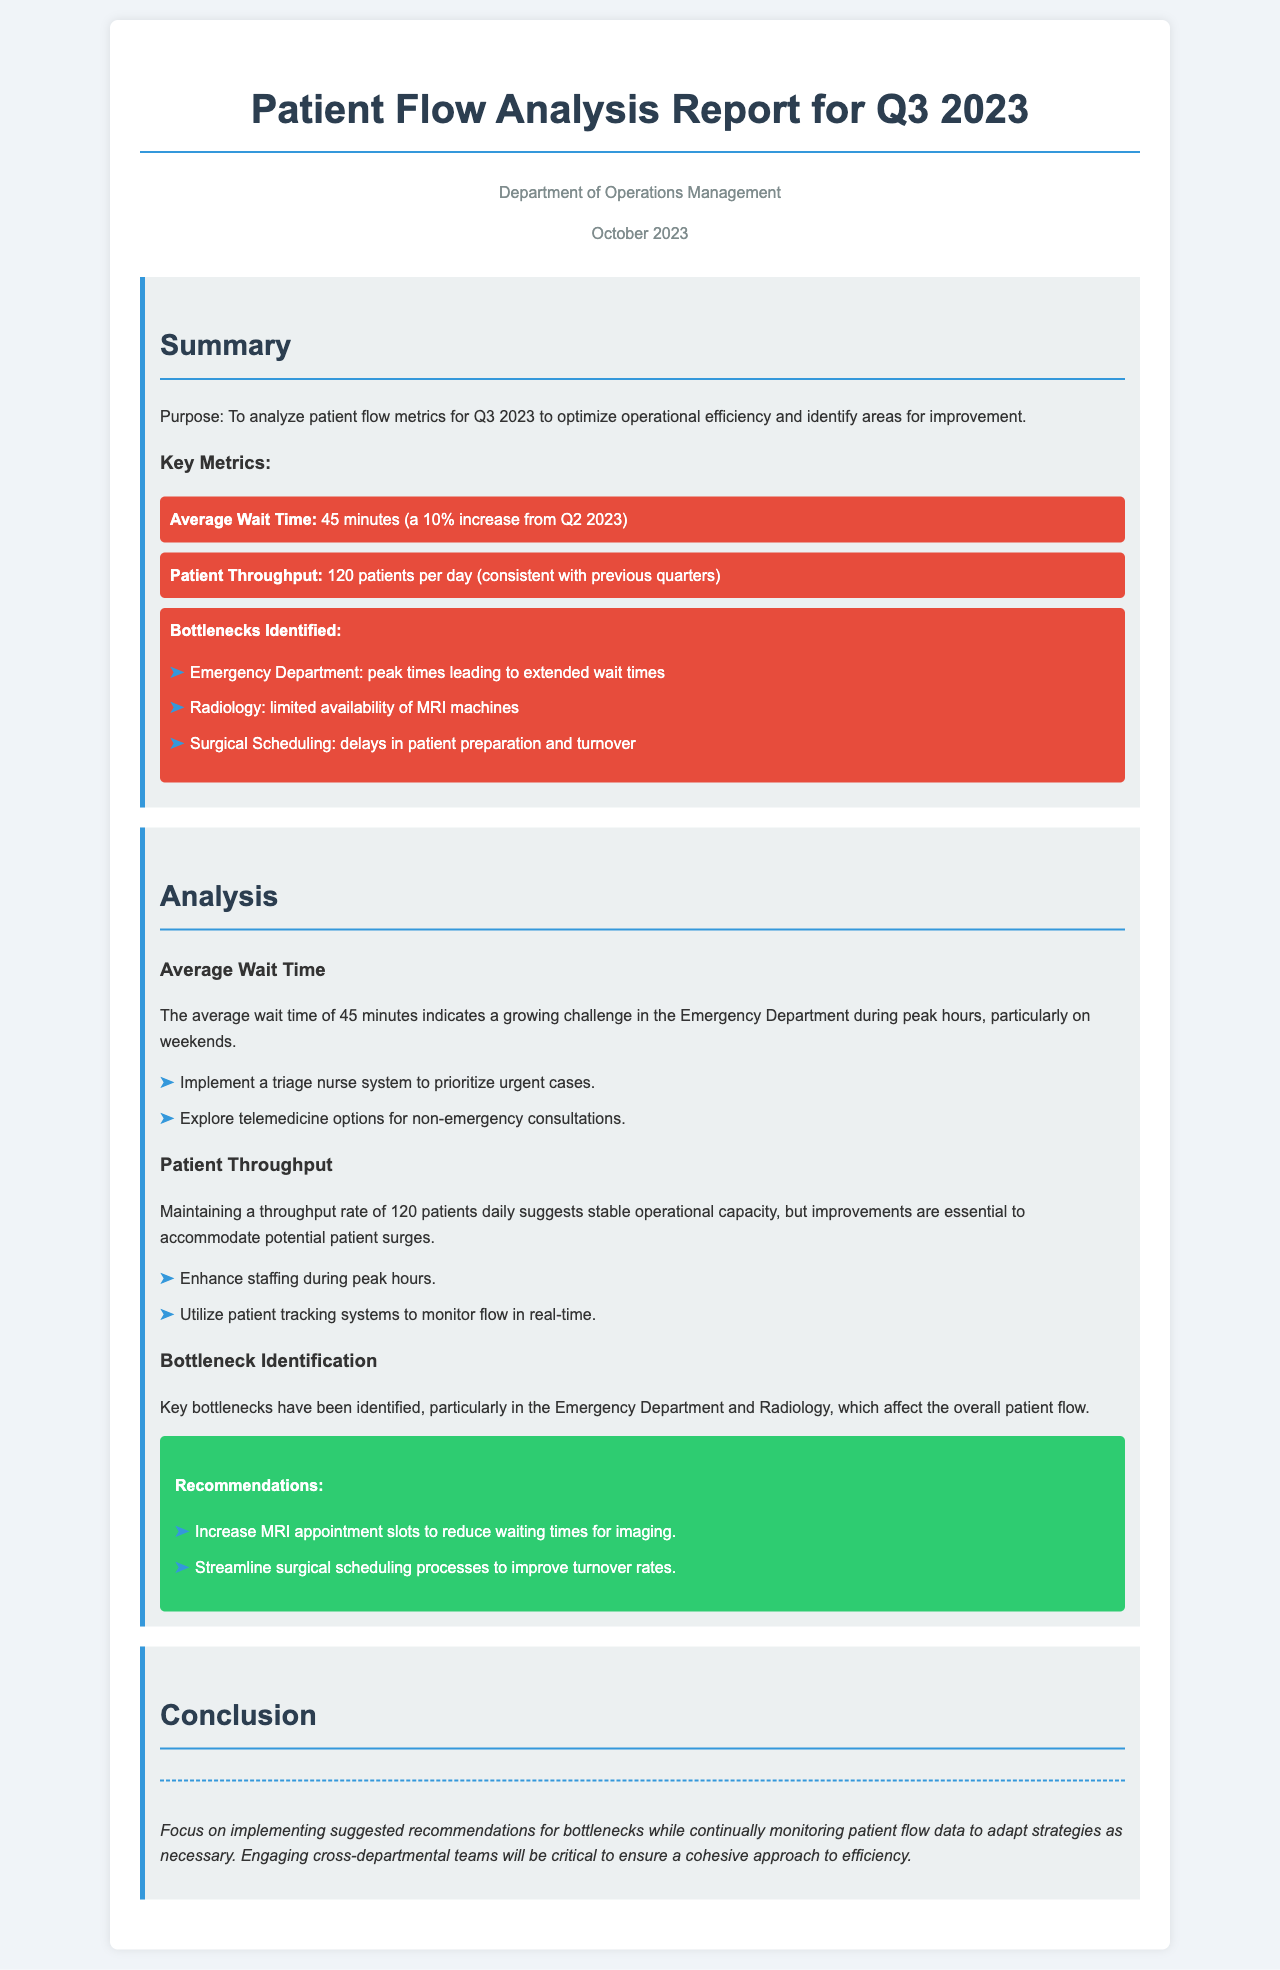What is the average wait time for Q3 2023? The average wait time of 45 minutes is reported for Q3 2023, indicating a 10% increase from Q2 2023.
Answer: 45 minutes How many patients are processed per day on average? The report states that the patient throughput is 120 patients per day, consistent with previous quarters.
Answer: 120 patients What is one identified bottleneck in the Emergency Department? The report highlights that peak times in the Emergency Department lead to extended wait times.
Answer: Extended wait times What recommendation is given to improve access to radiology services? The report suggests increasing MRI appointment slots to help reduce waiting times for imaging.
Answer: Increase MRI appointment slots What is the department responsible for the report? The report is created by the Department of Operations Management.
Answer: Department of Operations Management What is a suggested strategy to improve patient flow during peak hours? Implementing a triage nurse system to prioritize urgent cases is proposed in the report.
Answer: Triage nurse system What helps ensure a cohesive approach to efficiency according to the report? Engaging cross-departmental teams is emphasized as critical for achieving a cohesive approach.
Answer: Engaging cross-departmental teams 